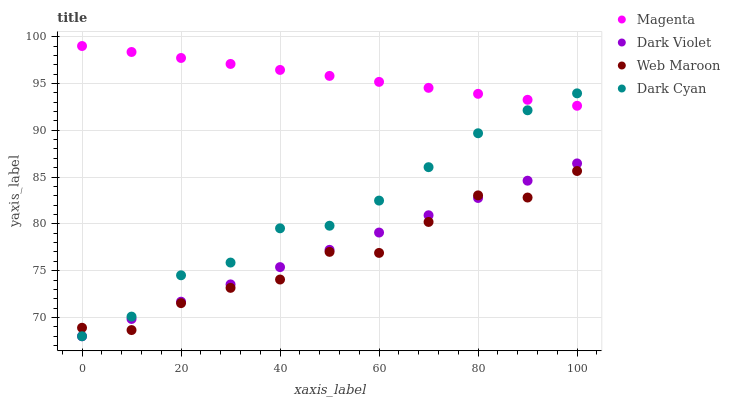Does Web Maroon have the minimum area under the curve?
Answer yes or no. Yes. Does Magenta have the maximum area under the curve?
Answer yes or no. Yes. Does Magenta have the minimum area under the curve?
Answer yes or no. No. Does Web Maroon have the maximum area under the curve?
Answer yes or no. No. Is Dark Violet the smoothest?
Answer yes or no. Yes. Is Web Maroon the roughest?
Answer yes or no. Yes. Is Magenta the smoothest?
Answer yes or no. No. Is Magenta the roughest?
Answer yes or no. No. Does Dark Cyan have the lowest value?
Answer yes or no. Yes. Does Web Maroon have the lowest value?
Answer yes or no. No. Does Magenta have the highest value?
Answer yes or no. Yes. Does Web Maroon have the highest value?
Answer yes or no. No. Is Dark Violet less than Magenta?
Answer yes or no. Yes. Is Magenta greater than Dark Violet?
Answer yes or no. Yes. Does Dark Violet intersect Dark Cyan?
Answer yes or no. Yes. Is Dark Violet less than Dark Cyan?
Answer yes or no. No. Is Dark Violet greater than Dark Cyan?
Answer yes or no. No. Does Dark Violet intersect Magenta?
Answer yes or no. No. 